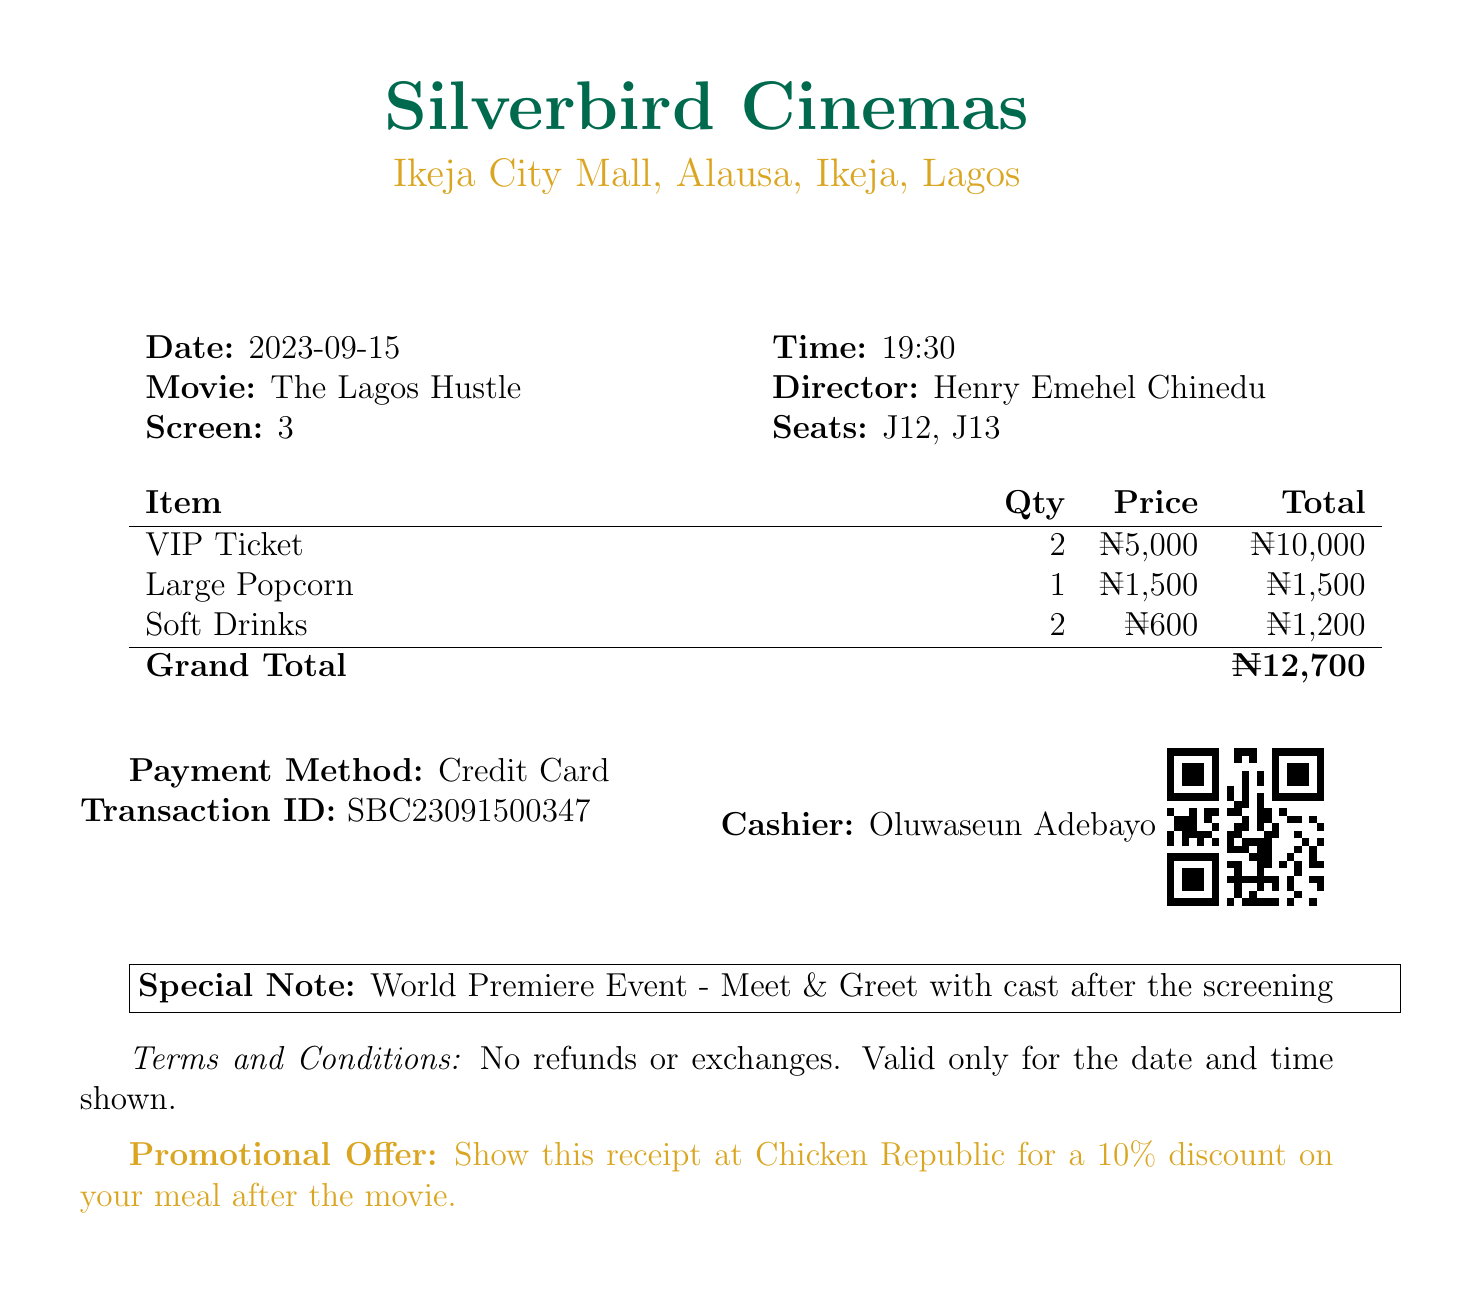What is the name of the cinema? The name of the cinema is provided in the document under the heading of the cinema.
Answer: Silverbird Cinemas What is the location of the cinema? The location is mentioned immediately below the cinema's name.
Answer: Ikeja City Mall, Alausa, Ikeja, Lagos What is the date of the film premiere? The date is listed clearly next to the label "Date:".
Answer: 2023-09-15 What movie was premiered? The movie title is specified in the document under the movie information section.
Answer: The Lagos Hustle How many VIP tickets were purchased? The quantity of tickets purchased is noted next to the item "VIP Ticket".
Answer: 2 What is the total amount spent on tickets? The total amount for tickets is calculated and shown in the total column for VIP tickets.
Answer: ₦10,000 What is the name of the director? The director's name is stated next to the label "Director:".
Answer: Henry Emehel Chinedu What is the total amount for additional items? The total for additional items is calculated and shown in the document.
Answer: ₦2,100 What is the grand total spent? The grand total reflects the sum of the ticket price and additional items.
Answer: ₦12,100 What is the promotional offer mentioned? The promotional offer is presented towards the end of the document.
Answer: Show this receipt at Chicken Republic for a 10% discount on your meal after the movie 